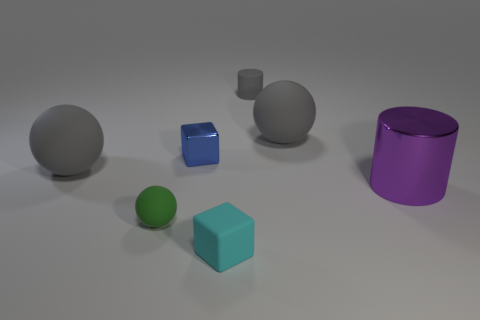Subtract all gray matte balls. How many balls are left? 1 Add 2 gray spheres. How many objects exist? 9 Subtract all gray cylinders. How many gray spheres are left? 2 Subtract 1 balls. How many balls are left? 2 Subtract all blocks. How many objects are left? 5 Subtract all red spheres. Subtract all cyan cylinders. How many spheres are left? 3 Add 4 small blue objects. How many small blue objects exist? 5 Subtract 0 gray cubes. How many objects are left? 7 Subtract all big gray rubber objects. Subtract all gray matte balls. How many objects are left? 3 Add 5 rubber cubes. How many rubber cubes are left? 6 